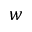Convert formula to latex. <formula><loc_0><loc_0><loc_500><loc_500>w</formula> 